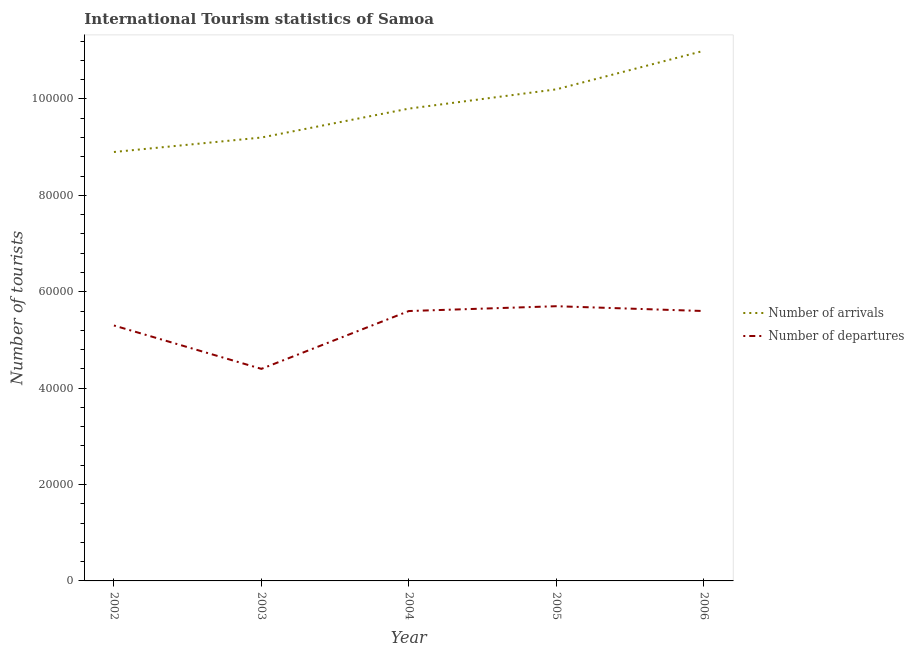Is the number of lines equal to the number of legend labels?
Give a very brief answer. Yes. What is the number of tourist arrivals in 2002?
Provide a short and direct response. 8.90e+04. Across all years, what is the maximum number of tourist arrivals?
Make the answer very short. 1.10e+05. Across all years, what is the minimum number of tourist arrivals?
Your answer should be very brief. 8.90e+04. In which year was the number of tourist departures minimum?
Give a very brief answer. 2003. What is the total number of tourist departures in the graph?
Your answer should be compact. 2.66e+05. What is the difference between the number of tourist departures in 2003 and that in 2006?
Make the answer very short. -1.20e+04. What is the difference between the number of tourist arrivals in 2006 and the number of tourist departures in 2005?
Give a very brief answer. 5.30e+04. What is the average number of tourist departures per year?
Provide a short and direct response. 5.32e+04. In the year 2005, what is the difference between the number of tourist arrivals and number of tourist departures?
Your response must be concise. 4.50e+04. What is the ratio of the number of tourist departures in 2003 to that in 2006?
Keep it short and to the point. 0.79. Is the difference between the number of tourist arrivals in 2002 and 2004 greater than the difference between the number of tourist departures in 2002 and 2004?
Offer a very short reply. No. What is the difference between the highest and the second highest number of tourist arrivals?
Ensure brevity in your answer.  8000. What is the difference between the highest and the lowest number of tourist arrivals?
Your answer should be very brief. 2.10e+04. Is the number of tourist departures strictly greater than the number of tourist arrivals over the years?
Provide a succinct answer. No. Is the number of tourist departures strictly less than the number of tourist arrivals over the years?
Make the answer very short. Yes. What is the difference between two consecutive major ticks on the Y-axis?
Ensure brevity in your answer.  2.00e+04. Are the values on the major ticks of Y-axis written in scientific E-notation?
Provide a succinct answer. No. Does the graph contain any zero values?
Offer a terse response. No. How are the legend labels stacked?
Provide a succinct answer. Vertical. What is the title of the graph?
Ensure brevity in your answer.  International Tourism statistics of Samoa. Does "Study and work" appear as one of the legend labels in the graph?
Your response must be concise. No. What is the label or title of the Y-axis?
Keep it short and to the point. Number of tourists. What is the Number of tourists in Number of arrivals in 2002?
Provide a succinct answer. 8.90e+04. What is the Number of tourists in Number of departures in 2002?
Your response must be concise. 5.30e+04. What is the Number of tourists of Number of arrivals in 2003?
Keep it short and to the point. 9.20e+04. What is the Number of tourists of Number of departures in 2003?
Make the answer very short. 4.40e+04. What is the Number of tourists of Number of arrivals in 2004?
Your answer should be very brief. 9.80e+04. What is the Number of tourists of Number of departures in 2004?
Make the answer very short. 5.60e+04. What is the Number of tourists of Number of arrivals in 2005?
Ensure brevity in your answer.  1.02e+05. What is the Number of tourists of Number of departures in 2005?
Your response must be concise. 5.70e+04. What is the Number of tourists of Number of departures in 2006?
Provide a short and direct response. 5.60e+04. Across all years, what is the maximum Number of tourists of Number of arrivals?
Provide a succinct answer. 1.10e+05. Across all years, what is the maximum Number of tourists in Number of departures?
Your response must be concise. 5.70e+04. Across all years, what is the minimum Number of tourists of Number of arrivals?
Provide a short and direct response. 8.90e+04. Across all years, what is the minimum Number of tourists in Number of departures?
Ensure brevity in your answer.  4.40e+04. What is the total Number of tourists in Number of arrivals in the graph?
Your response must be concise. 4.91e+05. What is the total Number of tourists in Number of departures in the graph?
Keep it short and to the point. 2.66e+05. What is the difference between the Number of tourists of Number of arrivals in 2002 and that in 2003?
Offer a terse response. -3000. What is the difference between the Number of tourists of Number of departures in 2002 and that in 2003?
Your answer should be compact. 9000. What is the difference between the Number of tourists in Number of arrivals in 2002 and that in 2004?
Your answer should be compact. -9000. What is the difference between the Number of tourists of Number of departures in 2002 and that in 2004?
Your answer should be very brief. -3000. What is the difference between the Number of tourists of Number of arrivals in 2002 and that in 2005?
Provide a succinct answer. -1.30e+04. What is the difference between the Number of tourists of Number of departures in 2002 and that in 2005?
Provide a succinct answer. -4000. What is the difference between the Number of tourists in Number of arrivals in 2002 and that in 2006?
Provide a short and direct response. -2.10e+04. What is the difference between the Number of tourists in Number of departures in 2002 and that in 2006?
Ensure brevity in your answer.  -3000. What is the difference between the Number of tourists in Number of arrivals in 2003 and that in 2004?
Your answer should be compact. -6000. What is the difference between the Number of tourists in Number of departures in 2003 and that in 2004?
Provide a short and direct response. -1.20e+04. What is the difference between the Number of tourists in Number of arrivals in 2003 and that in 2005?
Make the answer very short. -10000. What is the difference between the Number of tourists of Number of departures in 2003 and that in 2005?
Ensure brevity in your answer.  -1.30e+04. What is the difference between the Number of tourists in Number of arrivals in 2003 and that in 2006?
Your answer should be very brief. -1.80e+04. What is the difference between the Number of tourists in Number of departures in 2003 and that in 2006?
Offer a terse response. -1.20e+04. What is the difference between the Number of tourists in Number of arrivals in 2004 and that in 2005?
Give a very brief answer. -4000. What is the difference between the Number of tourists in Number of departures in 2004 and that in 2005?
Your answer should be compact. -1000. What is the difference between the Number of tourists in Number of arrivals in 2004 and that in 2006?
Offer a terse response. -1.20e+04. What is the difference between the Number of tourists of Number of arrivals in 2005 and that in 2006?
Make the answer very short. -8000. What is the difference between the Number of tourists in Number of arrivals in 2002 and the Number of tourists in Number of departures in 2003?
Ensure brevity in your answer.  4.50e+04. What is the difference between the Number of tourists in Number of arrivals in 2002 and the Number of tourists in Number of departures in 2004?
Provide a succinct answer. 3.30e+04. What is the difference between the Number of tourists in Number of arrivals in 2002 and the Number of tourists in Number of departures in 2005?
Provide a short and direct response. 3.20e+04. What is the difference between the Number of tourists of Number of arrivals in 2002 and the Number of tourists of Number of departures in 2006?
Make the answer very short. 3.30e+04. What is the difference between the Number of tourists in Number of arrivals in 2003 and the Number of tourists in Number of departures in 2004?
Give a very brief answer. 3.60e+04. What is the difference between the Number of tourists of Number of arrivals in 2003 and the Number of tourists of Number of departures in 2005?
Offer a terse response. 3.50e+04. What is the difference between the Number of tourists of Number of arrivals in 2003 and the Number of tourists of Number of departures in 2006?
Keep it short and to the point. 3.60e+04. What is the difference between the Number of tourists in Number of arrivals in 2004 and the Number of tourists in Number of departures in 2005?
Provide a succinct answer. 4.10e+04. What is the difference between the Number of tourists of Number of arrivals in 2004 and the Number of tourists of Number of departures in 2006?
Your answer should be very brief. 4.20e+04. What is the difference between the Number of tourists of Number of arrivals in 2005 and the Number of tourists of Number of departures in 2006?
Your response must be concise. 4.60e+04. What is the average Number of tourists in Number of arrivals per year?
Offer a terse response. 9.82e+04. What is the average Number of tourists of Number of departures per year?
Provide a short and direct response. 5.32e+04. In the year 2002, what is the difference between the Number of tourists in Number of arrivals and Number of tourists in Number of departures?
Your answer should be compact. 3.60e+04. In the year 2003, what is the difference between the Number of tourists in Number of arrivals and Number of tourists in Number of departures?
Keep it short and to the point. 4.80e+04. In the year 2004, what is the difference between the Number of tourists in Number of arrivals and Number of tourists in Number of departures?
Give a very brief answer. 4.20e+04. In the year 2005, what is the difference between the Number of tourists in Number of arrivals and Number of tourists in Number of departures?
Keep it short and to the point. 4.50e+04. In the year 2006, what is the difference between the Number of tourists of Number of arrivals and Number of tourists of Number of departures?
Provide a short and direct response. 5.40e+04. What is the ratio of the Number of tourists in Number of arrivals in 2002 to that in 2003?
Provide a short and direct response. 0.97. What is the ratio of the Number of tourists in Number of departures in 2002 to that in 2003?
Provide a short and direct response. 1.2. What is the ratio of the Number of tourists in Number of arrivals in 2002 to that in 2004?
Make the answer very short. 0.91. What is the ratio of the Number of tourists of Number of departures in 2002 to that in 2004?
Ensure brevity in your answer.  0.95. What is the ratio of the Number of tourists in Number of arrivals in 2002 to that in 2005?
Give a very brief answer. 0.87. What is the ratio of the Number of tourists of Number of departures in 2002 to that in 2005?
Offer a very short reply. 0.93. What is the ratio of the Number of tourists in Number of arrivals in 2002 to that in 2006?
Provide a succinct answer. 0.81. What is the ratio of the Number of tourists of Number of departures in 2002 to that in 2006?
Provide a succinct answer. 0.95. What is the ratio of the Number of tourists of Number of arrivals in 2003 to that in 2004?
Your answer should be compact. 0.94. What is the ratio of the Number of tourists in Number of departures in 2003 to that in 2004?
Give a very brief answer. 0.79. What is the ratio of the Number of tourists of Number of arrivals in 2003 to that in 2005?
Ensure brevity in your answer.  0.9. What is the ratio of the Number of tourists of Number of departures in 2003 to that in 2005?
Keep it short and to the point. 0.77. What is the ratio of the Number of tourists in Number of arrivals in 2003 to that in 2006?
Offer a terse response. 0.84. What is the ratio of the Number of tourists in Number of departures in 2003 to that in 2006?
Provide a short and direct response. 0.79. What is the ratio of the Number of tourists of Number of arrivals in 2004 to that in 2005?
Make the answer very short. 0.96. What is the ratio of the Number of tourists in Number of departures in 2004 to that in 2005?
Give a very brief answer. 0.98. What is the ratio of the Number of tourists in Number of arrivals in 2004 to that in 2006?
Offer a very short reply. 0.89. What is the ratio of the Number of tourists in Number of departures in 2004 to that in 2006?
Make the answer very short. 1. What is the ratio of the Number of tourists of Number of arrivals in 2005 to that in 2006?
Ensure brevity in your answer.  0.93. What is the ratio of the Number of tourists in Number of departures in 2005 to that in 2006?
Make the answer very short. 1.02. What is the difference between the highest and the second highest Number of tourists in Number of arrivals?
Ensure brevity in your answer.  8000. What is the difference between the highest and the second highest Number of tourists in Number of departures?
Your answer should be compact. 1000. What is the difference between the highest and the lowest Number of tourists in Number of arrivals?
Your answer should be compact. 2.10e+04. What is the difference between the highest and the lowest Number of tourists in Number of departures?
Keep it short and to the point. 1.30e+04. 